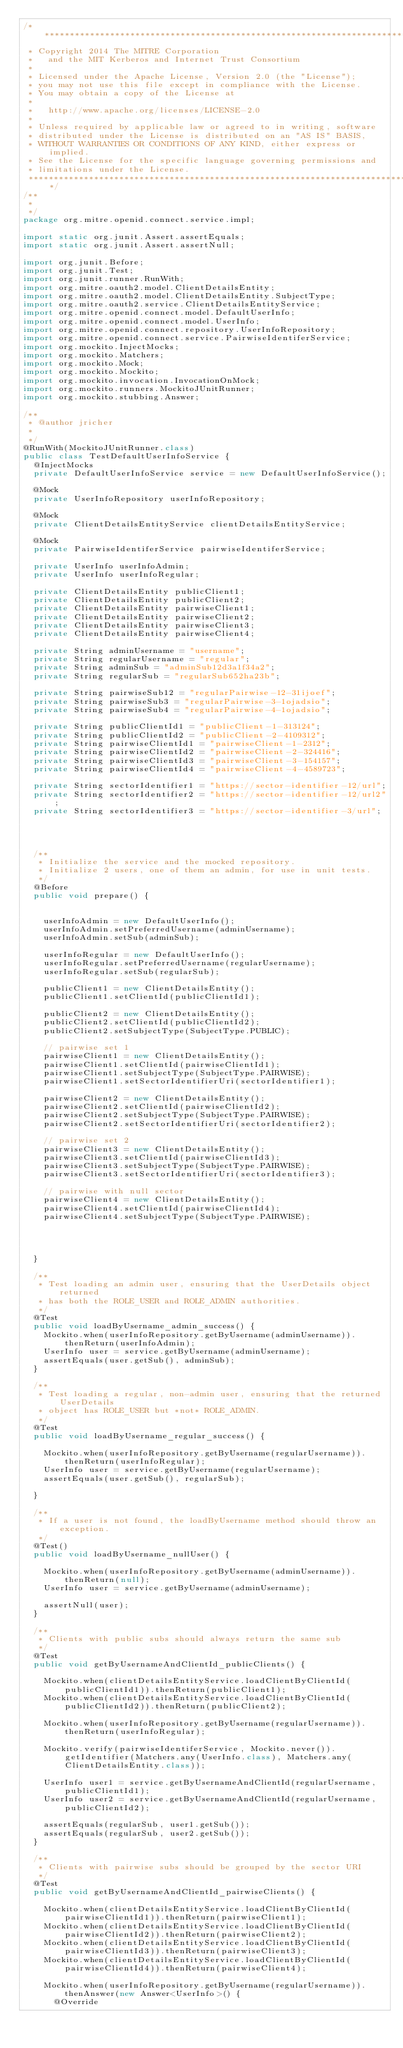<code> <loc_0><loc_0><loc_500><loc_500><_Java_>/*******************************************************************************
 * Copyright 2014 The MITRE Corporation
 *   and the MIT Kerberos and Internet Trust Consortium
 *
 * Licensed under the Apache License, Version 2.0 (the "License");
 * you may not use this file except in compliance with the License.
 * You may obtain a copy of the License at
 *
 *   http://www.apache.org/licenses/LICENSE-2.0
 *
 * Unless required by applicable law or agreed to in writing, software
 * distributed under the License is distributed on an "AS IS" BASIS,
 * WITHOUT WARRANTIES OR CONDITIONS OF ANY KIND, either express or implied.
 * See the License for the specific language governing permissions and
 * limitations under the License.
 *******************************************************************************/
/**
 * 
 */
package org.mitre.openid.connect.service.impl;

import static org.junit.Assert.assertEquals;
import static org.junit.Assert.assertNull;

import org.junit.Before;
import org.junit.Test;
import org.junit.runner.RunWith;
import org.mitre.oauth2.model.ClientDetailsEntity;
import org.mitre.oauth2.model.ClientDetailsEntity.SubjectType;
import org.mitre.oauth2.service.ClientDetailsEntityService;
import org.mitre.openid.connect.model.DefaultUserInfo;
import org.mitre.openid.connect.model.UserInfo;
import org.mitre.openid.connect.repository.UserInfoRepository;
import org.mitre.openid.connect.service.PairwiseIdentiferService;
import org.mockito.InjectMocks;
import org.mockito.Matchers;
import org.mockito.Mock;
import org.mockito.Mockito;
import org.mockito.invocation.InvocationOnMock;
import org.mockito.runners.MockitoJUnitRunner;
import org.mockito.stubbing.Answer;

/**
 * @author jricher
 *
 */
@RunWith(MockitoJUnitRunner.class)
public class TestDefaultUserInfoService {
	@InjectMocks
	private DefaultUserInfoService service = new DefaultUserInfoService();

	@Mock
	private UserInfoRepository userInfoRepository;

	@Mock
	private ClientDetailsEntityService clientDetailsEntityService;

	@Mock
	private PairwiseIdentiferService pairwiseIdentiferService;

	private UserInfo userInfoAdmin;
	private UserInfo userInfoRegular;

	private ClientDetailsEntity publicClient1;
	private ClientDetailsEntity publicClient2;
	private ClientDetailsEntity pairwiseClient1;
	private ClientDetailsEntity pairwiseClient2;
	private ClientDetailsEntity pairwiseClient3;
	private ClientDetailsEntity pairwiseClient4;

	private String adminUsername = "username";
	private String regularUsername = "regular";
	private String adminSub = "adminSub12d3a1f34a2";
	private String regularSub = "regularSub652ha23b";

	private String pairwiseSub12 = "regularPairwise-12-31ijoef";
	private String pairwiseSub3 = "regularPairwise-3-1ojadsio";
	private String pairwiseSub4 = "regularPairwise-4-1ojadsio";

	private String publicClientId1 = "publicClient-1-313124";
	private String publicClientId2 = "publicClient-2-4109312";
	private String pairwiseClientId1 = "pairwiseClient-1-2312";
	private String pairwiseClientId2 = "pairwiseClient-2-324416";
	private String pairwiseClientId3 = "pairwiseClient-3-154157";
	private String pairwiseClientId4 = "pairwiseClient-4-4589723";

	private String sectorIdentifier1 = "https://sector-identifier-12/url";
	private String sectorIdentifier2 = "https://sector-identifier-12/url2";
	private String sectorIdentifier3 = "https://sector-identifier-3/url";




	/**
	 * Initialize the service and the mocked repository.
	 * Initialize 2 users, one of them an admin, for use in unit tests.
	 */
	@Before
	public void prepare() {


		userInfoAdmin = new DefaultUserInfo();
		userInfoAdmin.setPreferredUsername(adminUsername);
		userInfoAdmin.setSub(adminSub);

		userInfoRegular = new DefaultUserInfo();
		userInfoRegular.setPreferredUsername(regularUsername);
		userInfoRegular.setSub(regularSub);

		publicClient1 = new ClientDetailsEntity();
		publicClient1.setClientId(publicClientId1);

		publicClient2 = new ClientDetailsEntity();
		publicClient2.setClientId(publicClientId2);
		publicClient2.setSubjectType(SubjectType.PUBLIC);

		// pairwise set 1
		pairwiseClient1 = new ClientDetailsEntity();
		pairwiseClient1.setClientId(pairwiseClientId1);
		pairwiseClient1.setSubjectType(SubjectType.PAIRWISE);
		pairwiseClient1.setSectorIdentifierUri(sectorIdentifier1);

		pairwiseClient2 = new ClientDetailsEntity();
		pairwiseClient2.setClientId(pairwiseClientId2);
		pairwiseClient2.setSubjectType(SubjectType.PAIRWISE);
		pairwiseClient2.setSectorIdentifierUri(sectorIdentifier2);

		// pairwise set 2
		pairwiseClient3 = new ClientDetailsEntity();
		pairwiseClient3.setClientId(pairwiseClientId3);
		pairwiseClient3.setSubjectType(SubjectType.PAIRWISE);
		pairwiseClient3.setSectorIdentifierUri(sectorIdentifier3);

		// pairwise with null sector
		pairwiseClient4 = new ClientDetailsEntity();
		pairwiseClient4.setClientId(pairwiseClientId4);
		pairwiseClient4.setSubjectType(SubjectType.PAIRWISE);




	}

	/**
	 * Test loading an admin user, ensuring that the UserDetails object returned
	 * has both the ROLE_USER and ROLE_ADMIN authorities.
	 */
	@Test
	public void loadByUsername_admin_success() {
		Mockito.when(userInfoRepository.getByUsername(adminUsername)).thenReturn(userInfoAdmin);
		UserInfo user = service.getByUsername(adminUsername);
		assertEquals(user.getSub(), adminSub);
	}

	/**
	 * Test loading a regular, non-admin user, ensuring that the returned UserDetails
	 * object has ROLE_USER but *not* ROLE_ADMIN.
	 */
	@Test
	public void loadByUsername_regular_success() {

		Mockito.when(userInfoRepository.getByUsername(regularUsername)).thenReturn(userInfoRegular);
		UserInfo user = service.getByUsername(regularUsername);
		assertEquals(user.getSub(), regularSub);

	}

	/**
	 * If a user is not found, the loadByUsername method should throw an exception.
	 */
	@Test()
	public void loadByUsername_nullUser() {

		Mockito.when(userInfoRepository.getByUsername(adminUsername)).thenReturn(null);
		UserInfo user = service.getByUsername(adminUsername);

		assertNull(user);
	}

	/**
	 * Clients with public subs should always return the same sub
	 */
	@Test
	public void getByUsernameAndClientId_publicClients() {

		Mockito.when(clientDetailsEntityService.loadClientByClientId(publicClientId1)).thenReturn(publicClient1);
		Mockito.when(clientDetailsEntityService.loadClientByClientId(publicClientId2)).thenReturn(publicClient2);

		Mockito.when(userInfoRepository.getByUsername(regularUsername)).thenReturn(userInfoRegular);

		Mockito.verify(pairwiseIdentiferService, Mockito.never()).getIdentifier(Matchers.any(UserInfo.class), Matchers.any(ClientDetailsEntity.class));

		UserInfo user1 = service.getByUsernameAndClientId(regularUsername, publicClientId1);
		UserInfo user2 = service.getByUsernameAndClientId(regularUsername, publicClientId2);

		assertEquals(regularSub, user1.getSub());
		assertEquals(regularSub, user2.getSub());
	}

	/**
	 * Clients with pairwise subs should be grouped by the sector URI
	 */
	@Test
	public void getByUsernameAndClientId_pairwiseClients() {

		Mockito.when(clientDetailsEntityService.loadClientByClientId(pairwiseClientId1)).thenReturn(pairwiseClient1);
		Mockito.when(clientDetailsEntityService.loadClientByClientId(pairwiseClientId2)).thenReturn(pairwiseClient2);
		Mockito.when(clientDetailsEntityService.loadClientByClientId(pairwiseClientId3)).thenReturn(pairwiseClient3);
		Mockito.when(clientDetailsEntityService.loadClientByClientId(pairwiseClientId4)).thenReturn(pairwiseClient4);

		Mockito.when(userInfoRepository.getByUsername(regularUsername)).thenAnswer(new Answer<UserInfo>() {
			@Override</code> 